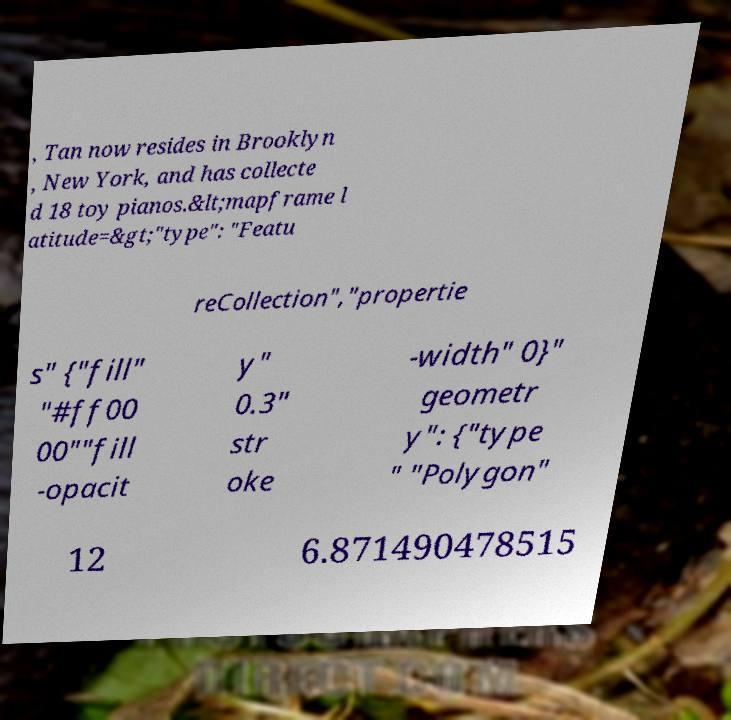Could you extract and type out the text from this image? , Tan now resides in Brooklyn , New York, and has collecte d 18 toy pianos.&lt;mapframe l atitude=&gt;"type": "Featu reCollection","propertie s" {"fill" "#ff00 00""fill -opacit y" 0.3" str oke -width" 0}" geometr y": {"type " "Polygon" 12 6.871490478515 